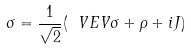Convert formula to latex. <formula><loc_0><loc_0><loc_500><loc_500>\sigma = \frac { 1 } { \sqrt { 2 } } ( \ V E V { \sigma } + \rho + i J )</formula> 